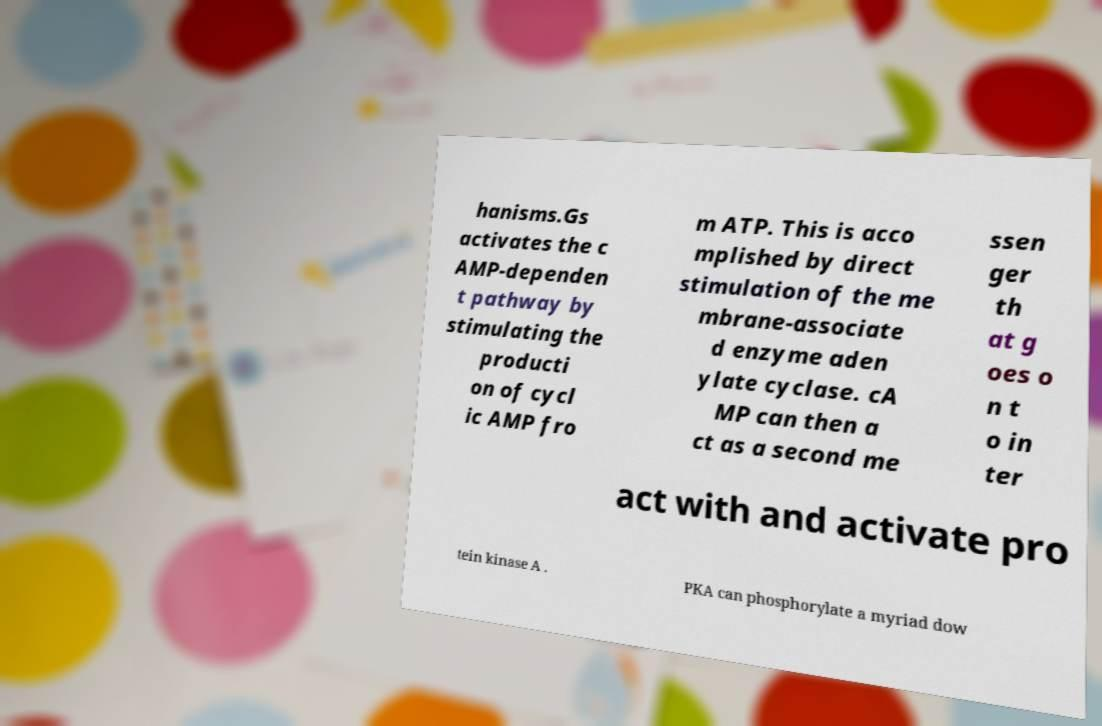Could you extract and type out the text from this image? hanisms.Gs activates the c AMP-dependen t pathway by stimulating the producti on of cycl ic AMP fro m ATP. This is acco mplished by direct stimulation of the me mbrane-associate d enzyme aden ylate cyclase. cA MP can then a ct as a second me ssen ger th at g oes o n t o in ter act with and activate pro tein kinase A . PKA can phosphorylate a myriad dow 